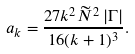Convert formula to latex. <formula><loc_0><loc_0><loc_500><loc_500>a _ { k } = \frac { 2 7 k ^ { 2 } \widetilde { N } ^ { 2 } \, | \Gamma | } { 1 6 ( k + 1 ) ^ { 3 } } .</formula> 